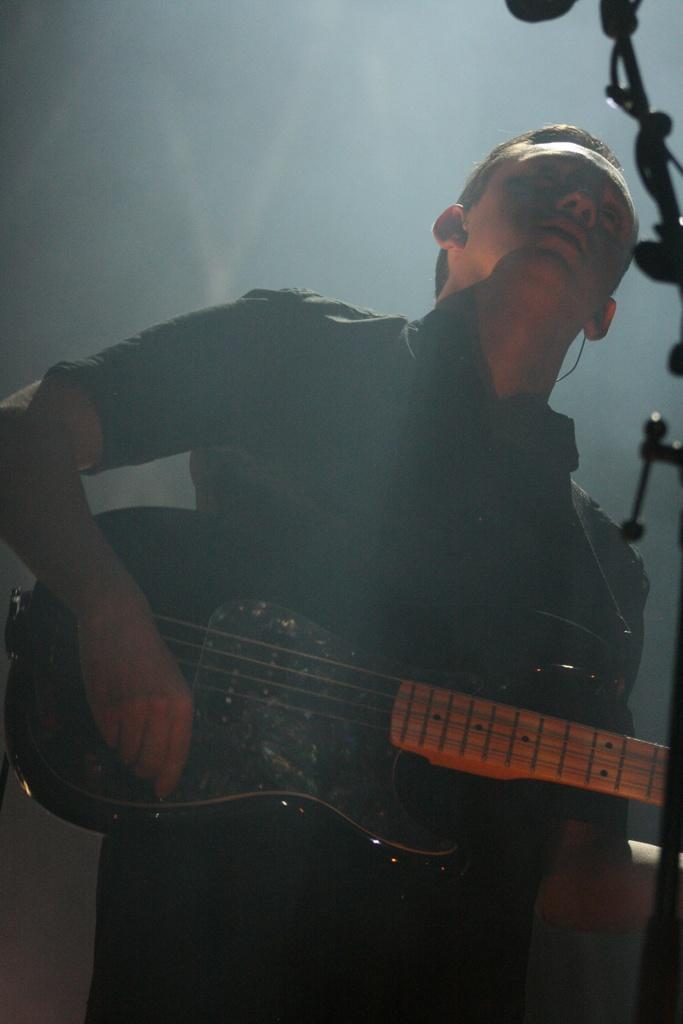Can you describe this image briefly? In his picture there is a boy who is standing at the center of the image by holding the guitar in his hand. 